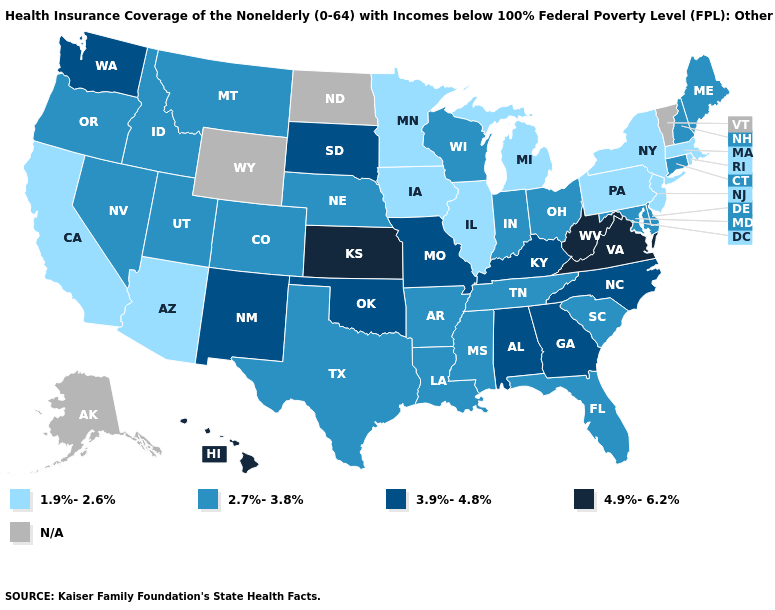Does the map have missing data?
Short answer required. Yes. Name the states that have a value in the range 4.9%-6.2%?
Concise answer only. Hawaii, Kansas, Virginia, West Virginia. Name the states that have a value in the range 1.9%-2.6%?
Keep it brief. Arizona, California, Illinois, Iowa, Massachusetts, Michigan, Minnesota, New Jersey, New York, Pennsylvania, Rhode Island. What is the value of Wisconsin?
Answer briefly. 2.7%-3.8%. How many symbols are there in the legend?
Keep it brief. 5. What is the lowest value in the USA?
Concise answer only. 1.9%-2.6%. Does the first symbol in the legend represent the smallest category?
Be succinct. Yes. Name the states that have a value in the range 2.7%-3.8%?
Keep it brief. Arkansas, Colorado, Connecticut, Delaware, Florida, Idaho, Indiana, Louisiana, Maine, Maryland, Mississippi, Montana, Nebraska, Nevada, New Hampshire, Ohio, Oregon, South Carolina, Tennessee, Texas, Utah, Wisconsin. What is the value of Colorado?
Be succinct. 2.7%-3.8%. What is the value of Alaska?
Concise answer only. N/A. Is the legend a continuous bar?
Quick response, please. No. Among the states that border Mississippi , does Alabama have the lowest value?
Concise answer only. No. Which states have the lowest value in the West?
Be succinct. Arizona, California. What is the value of Kentucky?
Concise answer only. 3.9%-4.8%. What is the lowest value in the USA?
Keep it brief. 1.9%-2.6%. 